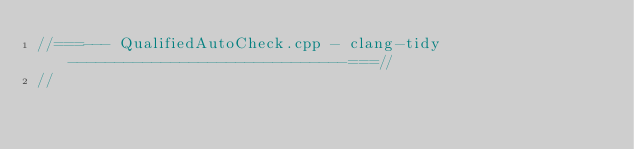Convert code to text. <code><loc_0><loc_0><loc_500><loc_500><_C++_>//===--- QualifiedAutoCheck.cpp - clang-tidy ------------------------------===//
//</code> 